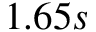Convert formula to latex. <formula><loc_0><loc_0><loc_500><loc_500>1 . 6 5 s</formula> 